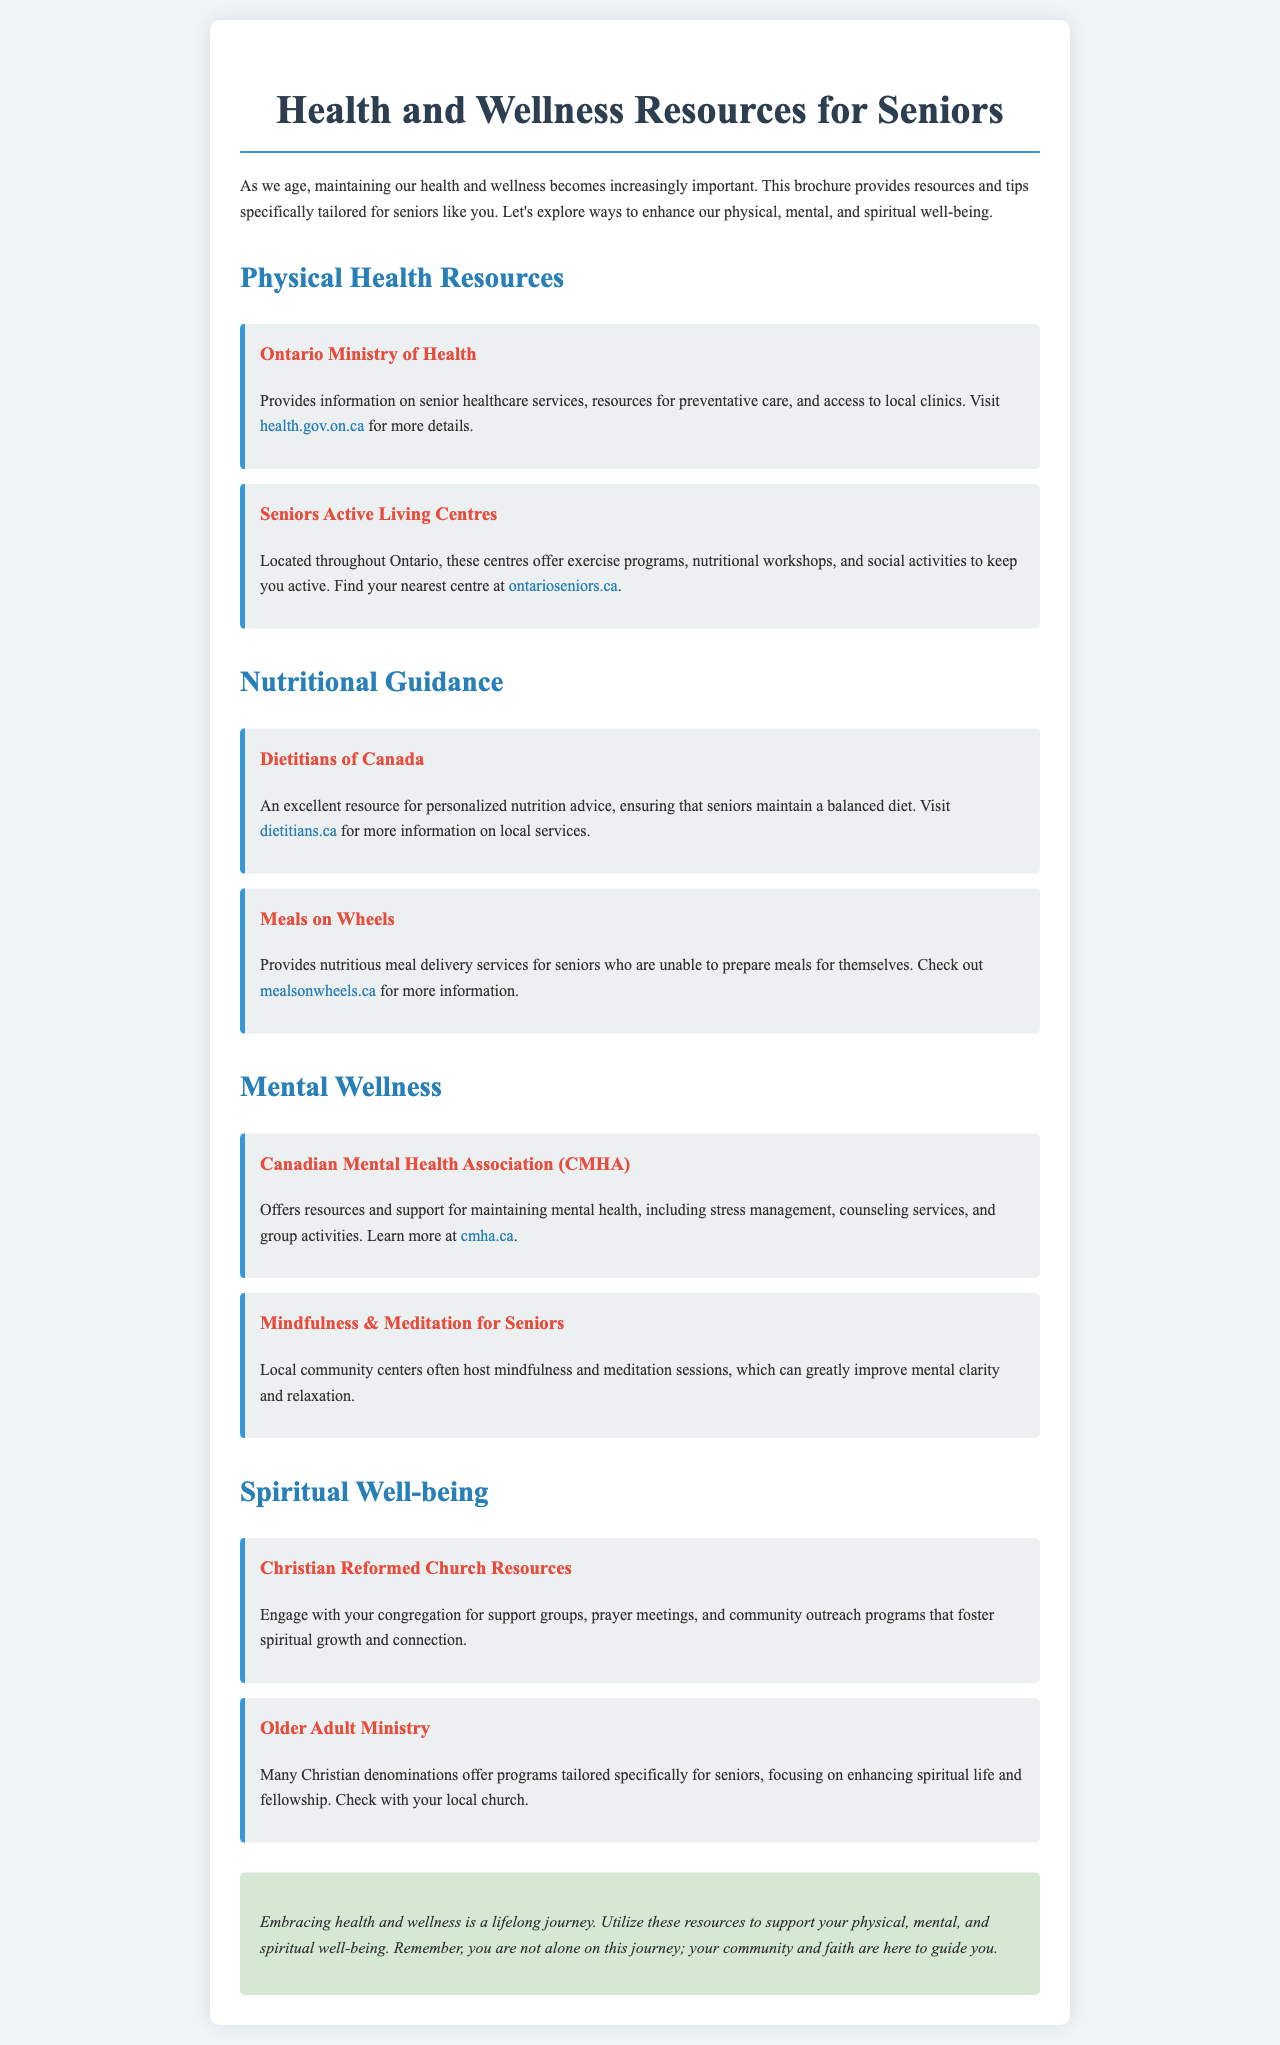what is the title of the brochure? The title is prominently displayed at the top of the document, stating the focus on health and wellness resources for seniors.
Answer: Health and Wellness Resources for Seniors what organization provides information on senior healthcare services? This organization is mentioned in the section about physical health resources, providing essential healthcare guidance.
Answer: Ontario Ministry of Health what service does Meals on Wheels offer? The document describes the service provided to support seniors who cannot prepare meals for themselves.
Answer: Nutritious meal delivery which association offers support for mental health? This association is specifically mentioned in the mental wellness section as a source of mental health resources.
Answer: Canadian Mental Health Association (CMHA) how many types of wellness are discussed in the brochure? The brochure categorizes wellness into four specific areas, each with dedicated resources.
Answer: Four what is a community activity mentioned for mental wellness? This activity is highlighted as beneficial for improving mental clarity and relaxation.
Answer: Mindfulness & Meditation sessions which church resources are offered for spiritual well-being? The document lists resources related to spiritual growth and support specifically appealing to members of the Christian faith.
Answer: Christian Reformed Church Resources where can you find nutritional advice tailored for seniors? The document highlights a specific organization that focuses on nutritional guidance for seniors.
Answer: Dietitians of Canada 